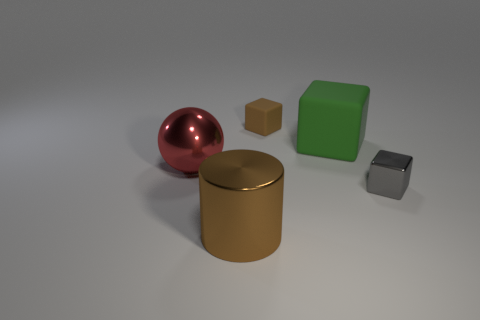The big thing that is behind the small gray cube and left of the small brown block is made of what material?
Offer a very short reply. Metal. There is a rubber thing that is behind the green block; does it have the same color as the metal thing on the right side of the metallic cylinder?
Provide a short and direct response. No. What number of other objects are there of the same size as the brown shiny object?
Your response must be concise. 2. Is there a small cube to the left of the rubber cube that is in front of the small object behind the gray object?
Keep it short and to the point. Yes. Does the tiny gray thing that is on the right side of the shiny cylinder have the same material as the green object?
Provide a succinct answer. No. What is the color of the large thing that is the same shape as the tiny matte object?
Ensure brevity in your answer.  Green. Is there anything else that is the same shape as the green object?
Give a very brief answer. Yes. Are there the same number of red objects that are behind the metal ball and big gray rubber spheres?
Give a very brief answer. Yes. Are there any tiny matte cubes behind the tiny brown rubber block?
Keep it short and to the point. No. What is the size of the brown thing on the left side of the tiny block that is left of the big thing to the right of the large brown thing?
Your answer should be compact. Large. 